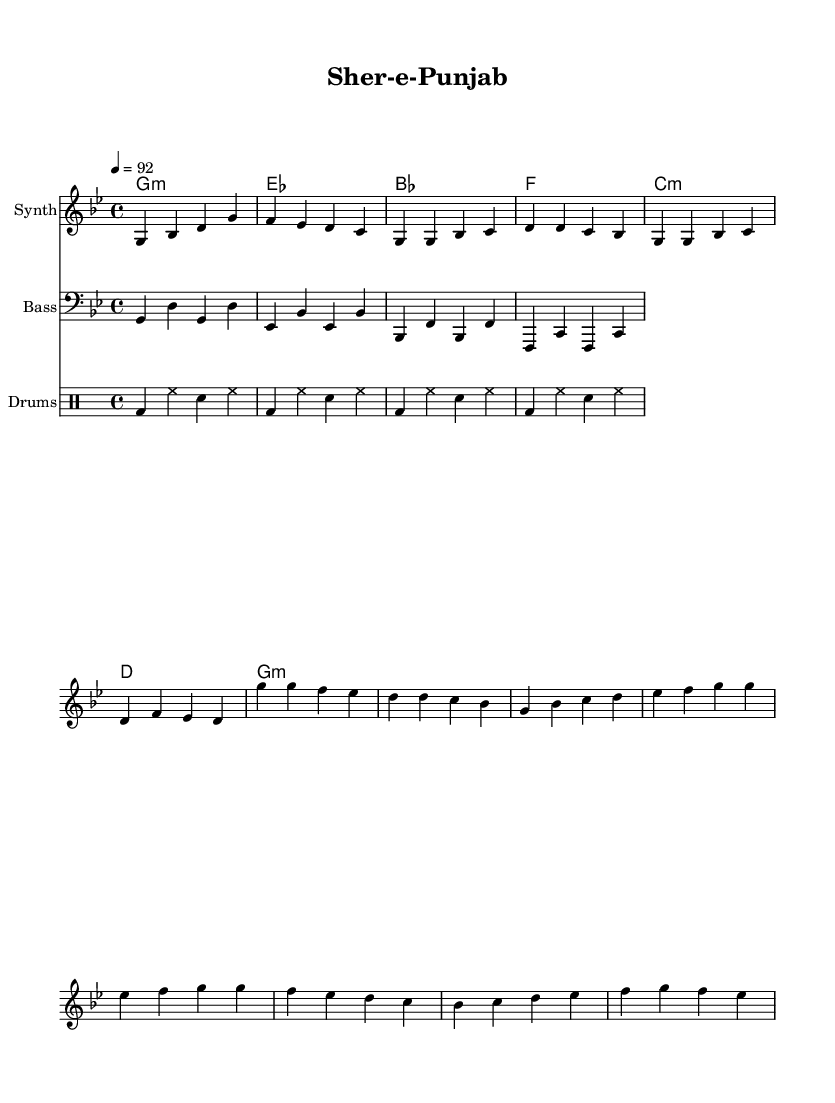What is the key signature of this music? The key signature is indicated by the presence of a flat sign (B flat) in the music. Since there are no other sharp or flat signs indicated, the key is G minor, which has two flats: B flat and E flat.
Answer: G minor What is the time signature? The time signature is written at the beginning of the music, displayed as a fraction. The top number (4) indicates that there are four beats in each measure, and the bottom number (4) indicates that a quarter note gets one beat. This establishes a 4/4 time signature.
Answer: 4/4 What is the tempo marking? The tempo marking is usually given in beats per minute (BPM) near the top of the music. In this case, it states "4 = 92", indicating that there are 92 beats per minute.
Answer: 92 How many measures are in the melody section? The melody section can be counted by looking at the phrases divided by vertical lines (bar lines) in the written music. Each phrase separated by these lines indicates one measure. By counting them, you can determine the total number of measures present. In the provided music, there are 8 measures in the melody section.
Answer: 8 What instruments are used in this piece? The instruments used are indicated at the beginning of each staff in the score. The first staff is labeled "Synth," the second one is "Bass," and the third one is for "Drums." This tells us what instruments will be playing the respective parts shown on those staves.
Answer: Synth, Bass, Drums What is the overall structure of the piece? The structure can be determined by identifying different labeled sections in the music. Here, we can see a division into an "Intro," "Verse 1," "Chorus," and a "Bridge." This indicates a common song structure for hip-hop where storytelling elements are used throughout.
Answer: Intro, Verse 1, Chorus, Bridge What type of rhythm pattern is used for the drums? The rhythm pattern for drums can be analyzed through the written drum notes which show hits for bass drum (bd), hi-hat (hh), and snare (sn). By observing the rhythmic sequence, one can see a repetitive pattern that establishes the groove of the piece. This often aligns with the hip hop style that emphasizes a steady backbeat.
Answer: Repetitive pattern 